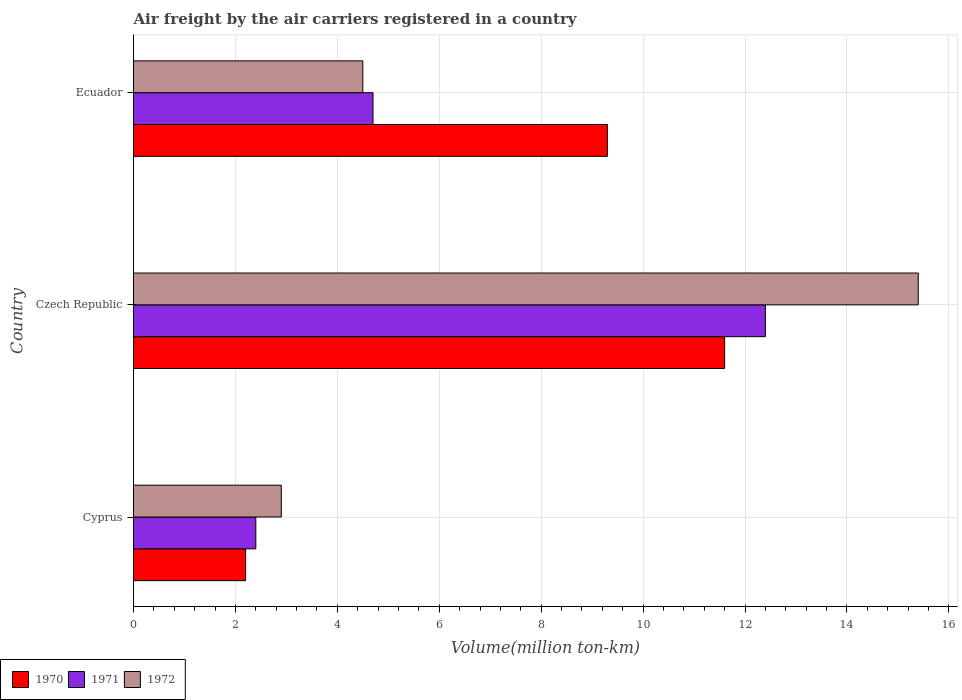How many different coloured bars are there?
Make the answer very short. 3. Are the number of bars per tick equal to the number of legend labels?
Ensure brevity in your answer.  Yes. How many bars are there on the 1st tick from the top?
Your response must be concise. 3. What is the label of the 1st group of bars from the top?
Provide a short and direct response. Ecuador. In how many cases, is the number of bars for a given country not equal to the number of legend labels?
Provide a succinct answer. 0. What is the volume of the air carriers in 1972 in Cyprus?
Ensure brevity in your answer.  2.9. Across all countries, what is the maximum volume of the air carriers in 1971?
Your answer should be very brief. 12.4. Across all countries, what is the minimum volume of the air carriers in 1972?
Offer a very short reply. 2.9. In which country was the volume of the air carriers in 1972 maximum?
Your answer should be compact. Czech Republic. In which country was the volume of the air carriers in 1972 minimum?
Make the answer very short. Cyprus. What is the total volume of the air carriers in 1970 in the graph?
Provide a succinct answer. 23.1. What is the difference between the volume of the air carriers in 1972 in Cyprus and that in Czech Republic?
Ensure brevity in your answer.  -12.5. What is the difference between the volume of the air carriers in 1972 in Czech Republic and the volume of the air carriers in 1971 in Cyprus?
Provide a succinct answer. 13. What is the average volume of the air carriers in 1970 per country?
Ensure brevity in your answer.  7.7. What is the difference between the volume of the air carriers in 1972 and volume of the air carriers in 1971 in Ecuador?
Offer a very short reply. -0.2. What is the ratio of the volume of the air carriers in 1972 in Cyprus to that in Ecuador?
Your answer should be very brief. 0.64. Is the volume of the air carriers in 1970 in Czech Republic less than that in Ecuador?
Provide a succinct answer. No. Is the difference between the volume of the air carriers in 1972 in Cyprus and Ecuador greater than the difference between the volume of the air carriers in 1971 in Cyprus and Ecuador?
Provide a short and direct response. Yes. What is the difference between the highest and the second highest volume of the air carriers in 1972?
Offer a terse response. 10.9. What is the difference between the highest and the lowest volume of the air carriers in 1972?
Your answer should be compact. 12.5. In how many countries, is the volume of the air carriers in 1971 greater than the average volume of the air carriers in 1971 taken over all countries?
Give a very brief answer. 1. What does the 1st bar from the bottom in Ecuador represents?
Provide a succinct answer. 1970. Is it the case that in every country, the sum of the volume of the air carriers in 1971 and volume of the air carriers in 1970 is greater than the volume of the air carriers in 1972?
Your answer should be very brief. Yes. What is the title of the graph?
Your response must be concise. Air freight by the air carriers registered in a country. Does "1997" appear as one of the legend labels in the graph?
Keep it short and to the point. No. What is the label or title of the X-axis?
Make the answer very short. Volume(million ton-km). What is the Volume(million ton-km) in 1970 in Cyprus?
Your answer should be very brief. 2.2. What is the Volume(million ton-km) in 1971 in Cyprus?
Provide a short and direct response. 2.4. What is the Volume(million ton-km) of 1972 in Cyprus?
Your answer should be very brief. 2.9. What is the Volume(million ton-km) of 1970 in Czech Republic?
Your answer should be compact. 11.6. What is the Volume(million ton-km) of 1971 in Czech Republic?
Your answer should be compact. 12.4. What is the Volume(million ton-km) in 1972 in Czech Republic?
Your answer should be compact. 15.4. What is the Volume(million ton-km) in 1970 in Ecuador?
Keep it short and to the point. 9.3. What is the Volume(million ton-km) in 1971 in Ecuador?
Provide a short and direct response. 4.7. What is the Volume(million ton-km) in 1972 in Ecuador?
Give a very brief answer. 4.5. Across all countries, what is the maximum Volume(million ton-km) of 1970?
Offer a terse response. 11.6. Across all countries, what is the maximum Volume(million ton-km) of 1971?
Offer a terse response. 12.4. Across all countries, what is the maximum Volume(million ton-km) of 1972?
Provide a short and direct response. 15.4. Across all countries, what is the minimum Volume(million ton-km) in 1970?
Keep it short and to the point. 2.2. Across all countries, what is the minimum Volume(million ton-km) in 1971?
Make the answer very short. 2.4. Across all countries, what is the minimum Volume(million ton-km) of 1972?
Provide a short and direct response. 2.9. What is the total Volume(million ton-km) in 1970 in the graph?
Make the answer very short. 23.1. What is the total Volume(million ton-km) of 1971 in the graph?
Give a very brief answer. 19.5. What is the total Volume(million ton-km) of 1972 in the graph?
Make the answer very short. 22.8. What is the difference between the Volume(million ton-km) of 1970 in Cyprus and that in Czech Republic?
Provide a succinct answer. -9.4. What is the difference between the Volume(million ton-km) in 1971 in Cyprus and that in Czech Republic?
Give a very brief answer. -10. What is the difference between the Volume(million ton-km) of 1972 in Cyprus and that in Czech Republic?
Offer a very short reply. -12.5. What is the difference between the Volume(million ton-km) in 1970 in Cyprus and that in Ecuador?
Offer a terse response. -7.1. What is the difference between the Volume(million ton-km) in 1971 in Cyprus and that in Ecuador?
Your answer should be compact. -2.3. What is the difference between the Volume(million ton-km) of 1972 in Cyprus and that in Ecuador?
Your response must be concise. -1.6. What is the difference between the Volume(million ton-km) in 1970 in Czech Republic and that in Ecuador?
Give a very brief answer. 2.3. What is the difference between the Volume(million ton-km) of 1971 in Czech Republic and that in Ecuador?
Keep it short and to the point. 7.7. What is the difference between the Volume(million ton-km) in 1970 in Cyprus and the Volume(million ton-km) in 1971 in Czech Republic?
Keep it short and to the point. -10.2. What is the difference between the Volume(million ton-km) of 1970 in Cyprus and the Volume(million ton-km) of 1972 in Czech Republic?
Your answer should be compact. -13.2. What is the difference between the Volume(million ton-km) in 1970 in Cyprus and the Volume(million ton-km) in 1971 in Ecuador?
Offer a very short reply. -2.5. What is the difference between the Volume(million ton-km) in 1970 in Cyprus and the Volume(million ton-km) in 1972 in Ecuador?
Your answer should be compact. -2.3. What is the difference between the Volume(million ton-km) of 1971 in Cyprus and the Volume(million ton-km) of 1972 in Ecuador?
Offer a terse response. -2.1. What is the difference between the Volume(million ton-km) in 1971 in Czech Republic and the Volume(million ton-km) in 1972 in Ecuador?
Provide a short and direct response. 7.9. What is the difference between the Volume(million ton-km) in 1970 and Volume(million ton-km) in 1971 in Cyprus?
Provide a succinct answer. -0.2. What is the difference between the Volume(million ton-km) of 1971 and Volume(million ton-km) of 1972 in Cyprus?
Your answer should be compact. -0.5. What is the difference between the Volume(million ton-km) in 1971 and Volume(million ton-km) in 1972 in Czech Republic?
Your answer should be very brief. -3. What is the difference between the Volume(million ton-km) in 1971 and Volume(million ton-km) in 1972 in Ecuador?
Offer a very short reply. 0.2. What is the ratio of the Volume(million ton-km) of 1970 in Cyprus to that in Czech Republic?
Give a very brief answer. 0.19. What is the ratio of the Volume(million ton-km) of 1971 in Cyprus to that in Czech Republic?
Your response must be concise. 0.19. What is the ratio of the Volume(million ton-km) of 1972 in Cyprus to that in Czech Republic?
Keep it short and to the point. 0.19. What is the ratio of the Volume(million ton-km) of 1970 in Cyprus to that in Ecuador?
Provide a short and direct response. 0.24. What is the ratio of the Volume(million ton-km) in 1971 in Cyprus to that in Ecuador?
Make the answer very short. 0.51. What is the ratio of the Volume(million ton-km) of 1972 in Cyprus to that in Ecuador?
Give a very brief answer. 0.64. What is the ratio of the Volume(million ton-km) in 1970 in Czech Republic to that in Ecuador?
Make the answer very short. 1.25. What is the ratio of the Volume(million ton-km) in 1971 in Czech Republic to that in Ecuador?
Provide a succinct answer. 2.64. What is the ratio of the Volume(million ton-km) of 1972 in Czech Republic to that in Ecuador?
Your answer should be very brief. 3.42. 